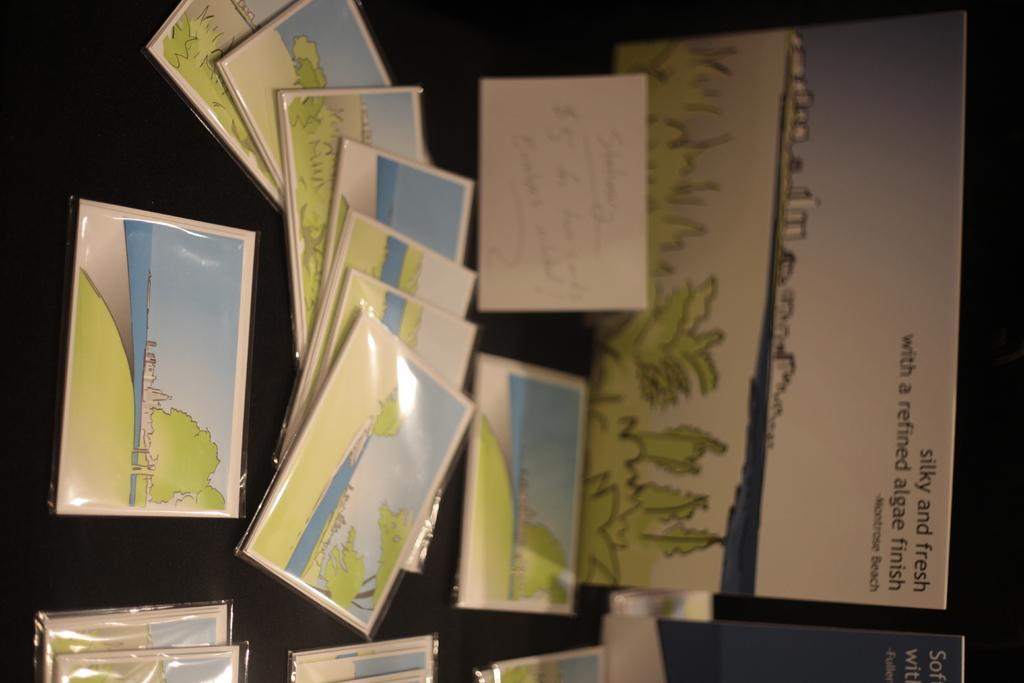<image>
Present a compact description of the photo's key features. A stack of post cards are on a table by a sign that says silky and fresh. 